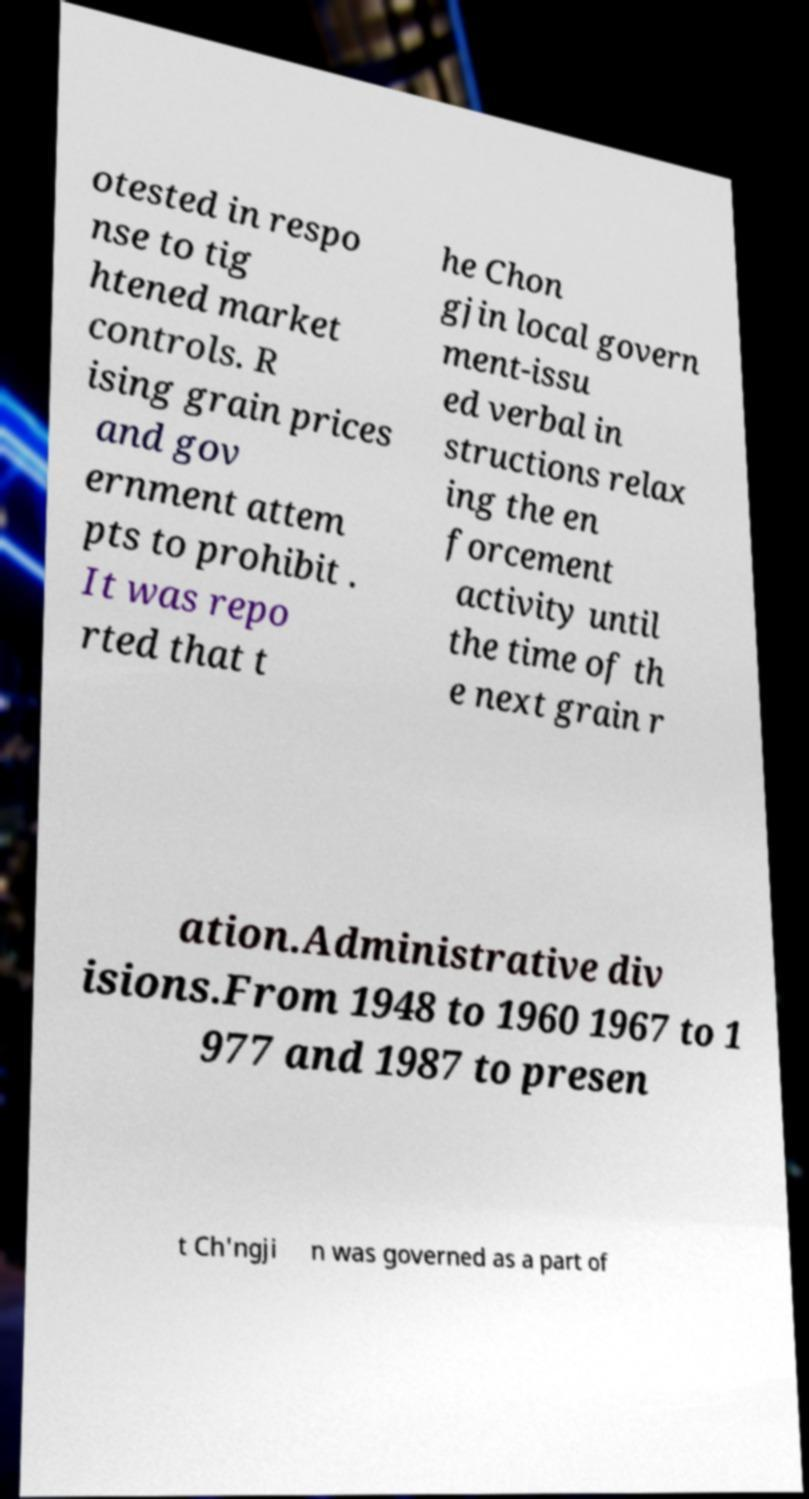There's text embedded in this image that I need extracted. Can you transcribe it verbatim? otested in respo nse to tig htened market controls. R ising grain prices and gov ernment attem pts to prohibit . It was repo rted that t he Chon gjin local govern ment-issu ed verbal in structions relax ing the en forcement activity until the time of th e next grain r ation.Administrative div isions.From 1948 to 1960 1967 to 1 977 and 1987 to presen t Ch'ngji n was governed as a part of 